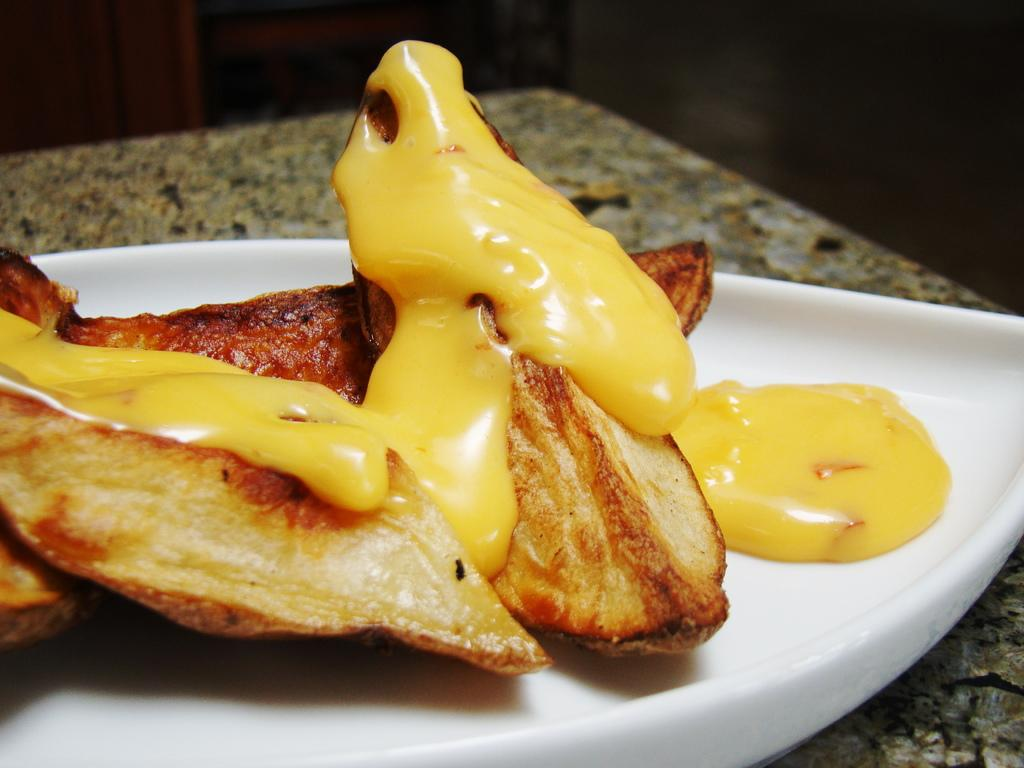What type of objects are present on the plates in the image? There are food items on the plates in the image. What is the color of the plates? The plates are white in color. What is the appearance of the food items? The food items have yellow color cream on them. Are there any islands visible in the image? No, there are no islands present in the image. What type of vegetable is mixed with the food items in the image? There is no vegetable mentioned in the provided facts, and the image does not show any vegetables. 